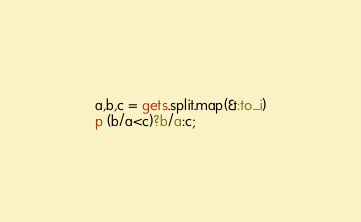Convert code to text. <code><loc_0><loc_0><loc_500><loc_500><_Ruby_>a,b,c = gets.split.map(&:to_i)
p (b/a<c)?b/a:c;
</code> 